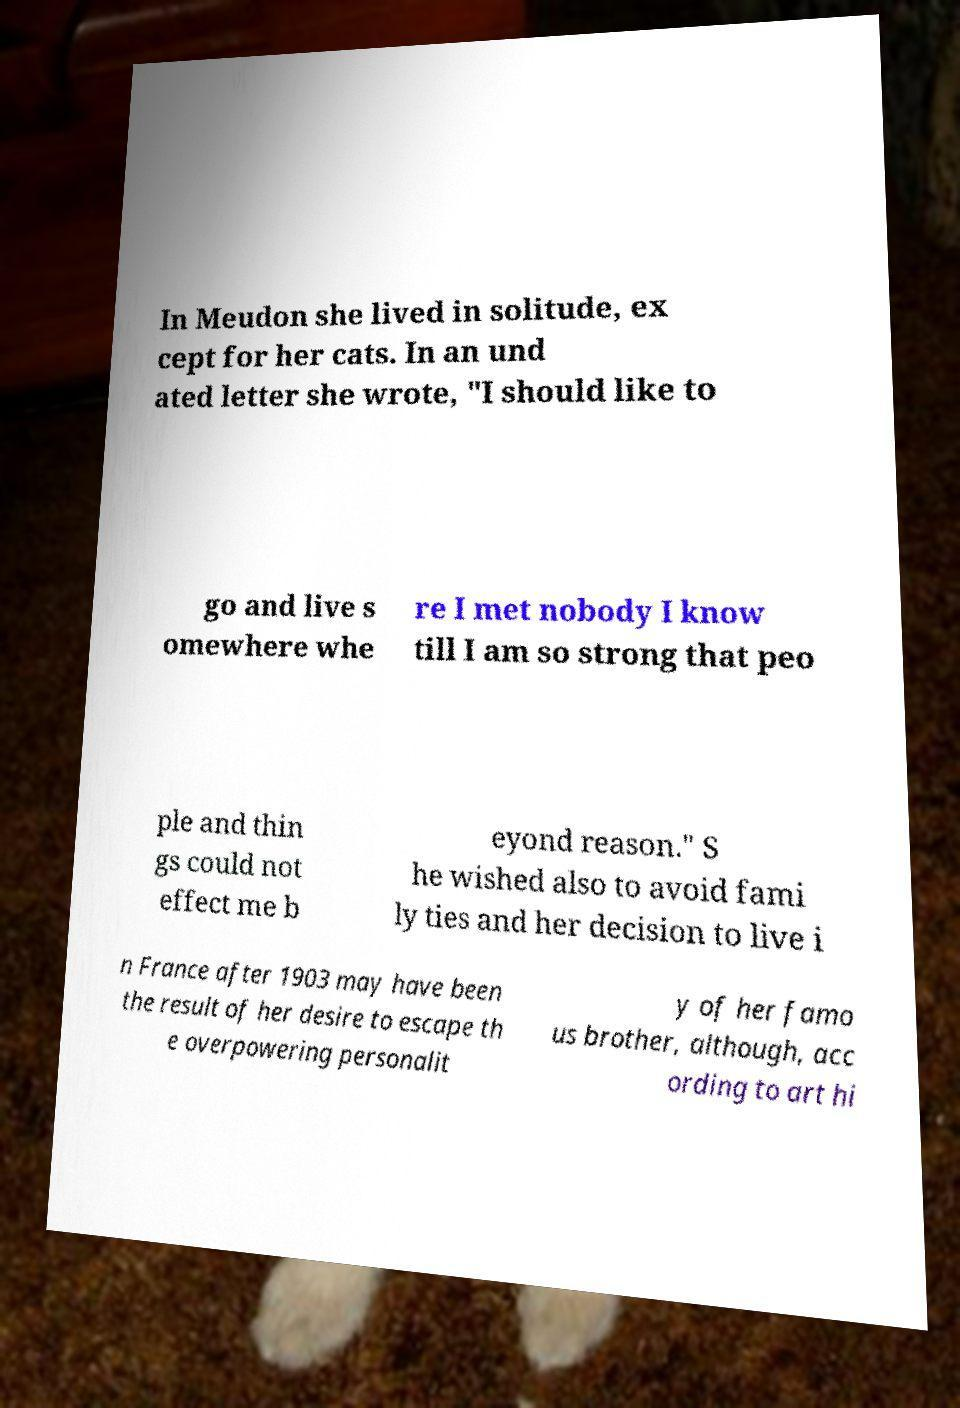Can you read and provide the text displayed in the image?This photo seems to have some interesting text. Can you extract and type it out for me? In Meudon she lived in solitude, ex cept for her cats. In an und ated letter she wrote, "I should like to go and live s omewhere whe re I met nobody I know till I am so strong that peo ple and thin gs could not effect me b eyond reason." S he wished also to avoid fami ly ties and her decision to live i n France after 1903 may have been the result of her desire to escape th e overpowering personalit y of her famo us brother, although, acc ording to art hi 